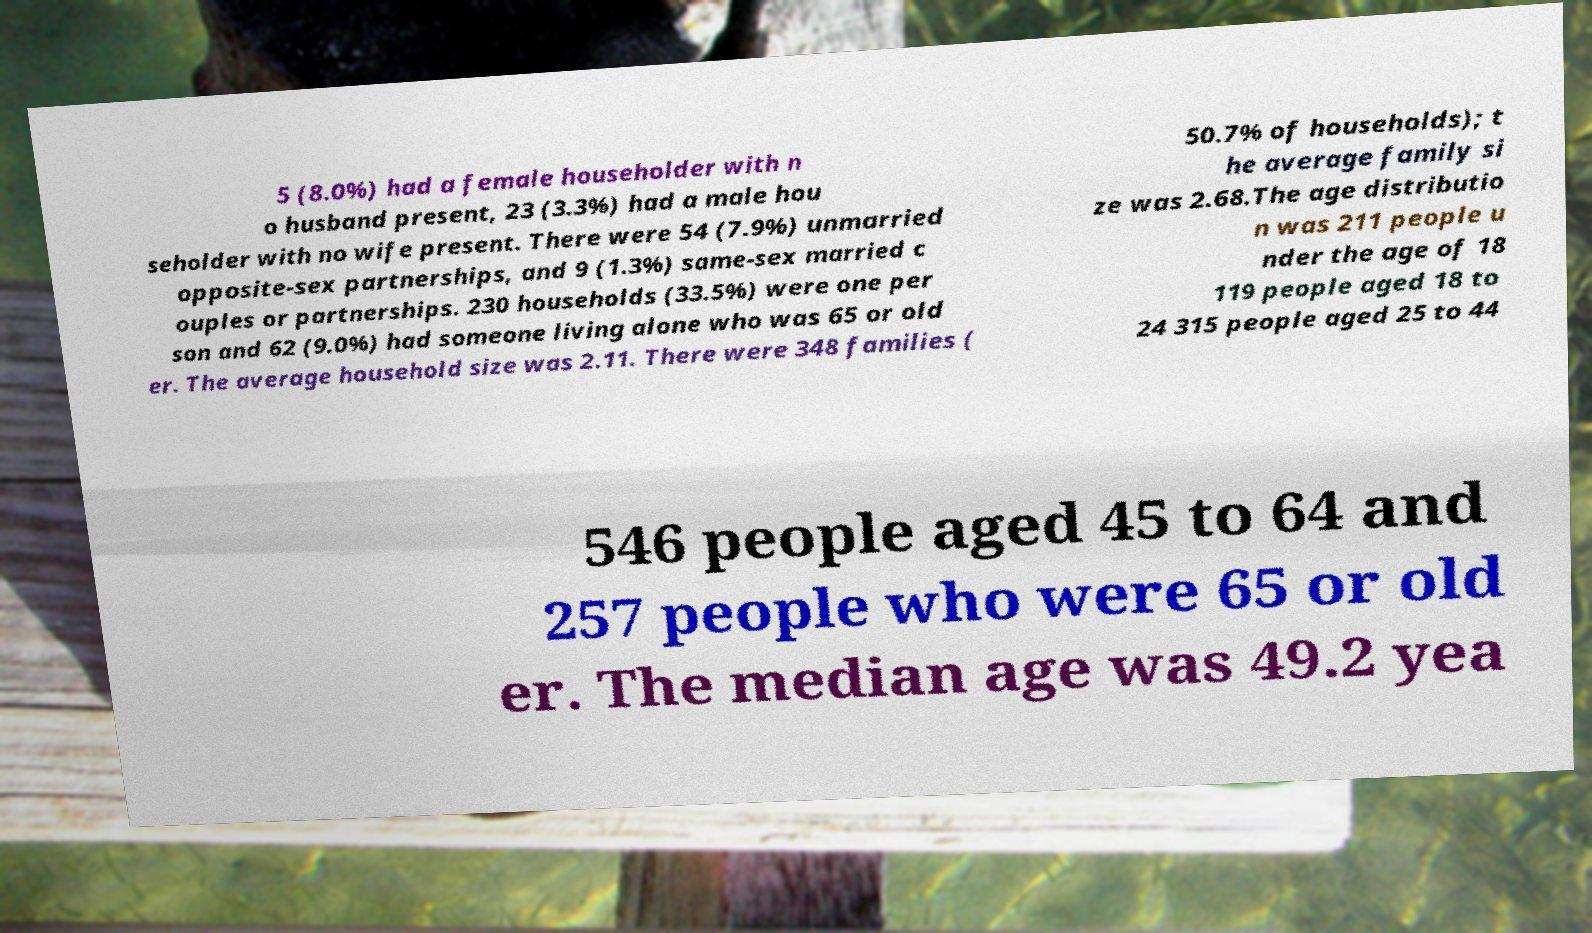Can you accurately transcribe the text from the provided image for me? 5 (8.0%) had a female householder with n o husband present, 23 (3.3%) had a male hou seholder with no wife present. There were 54 (7.9%) unmarried opposite-sex partnerships, and 9 (1.3%) same-sex married c ouples or partnerships. 230 households (33.5%) were one per son and 62 (9.0%) had someone living alone who was 65 or old er. The average household size was 2.11. There were 348 families ( 50.7% of households); t he average family si ze was 2.68.The age distributio n was 211 people u nder the age of 18 119 people aged 18 to 24 315 people aged 25 to 44 546 people aged 45 to 64 and 257 people who were 65 or old er. The median age was 49.2 yea 